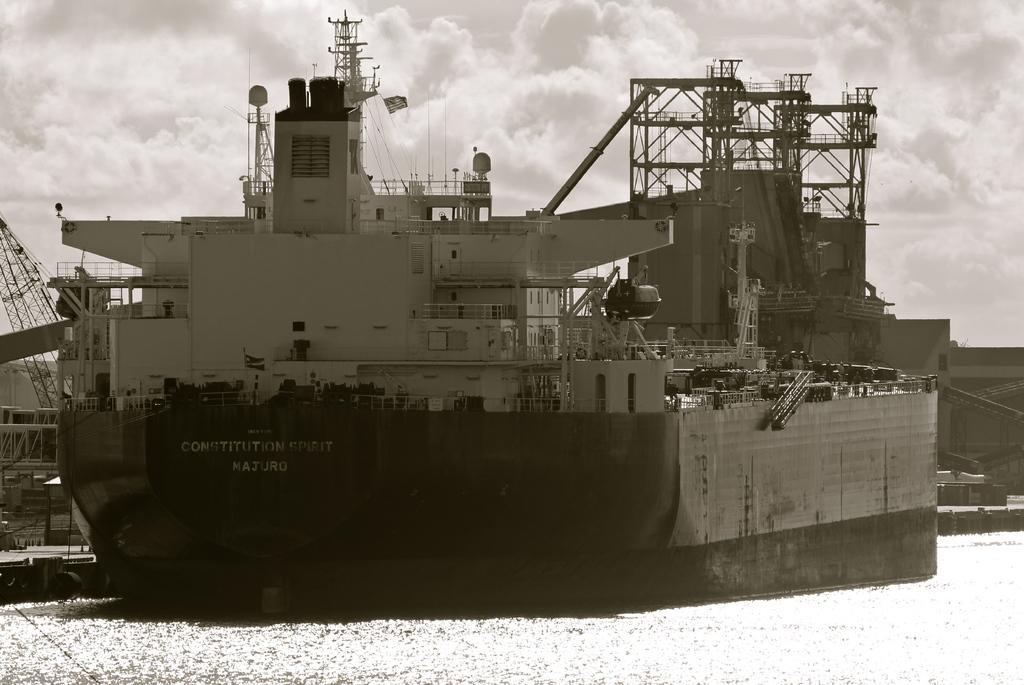Please provide a concise description of this image. In the image there is a troop ship on the water surface, it is very huge. 